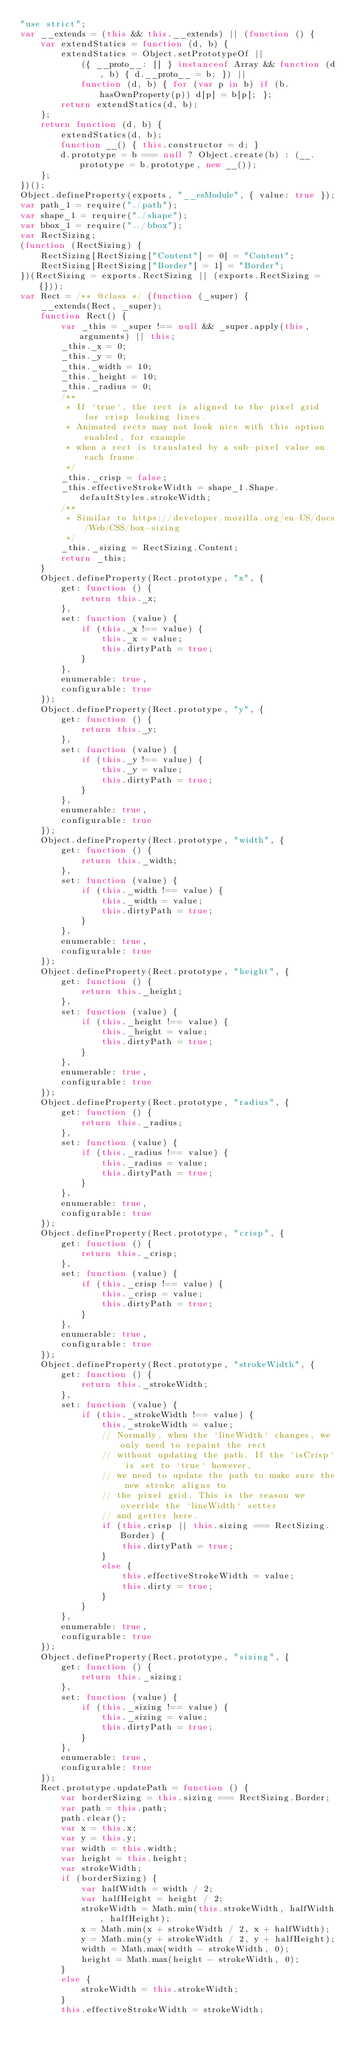<code> <loc_0><loc_0><loc_500><loc_500><_JavaScript_>"use strict";
var __extends = (this && this.__extends) || (function () {
    var extendStatics = function (d, b) {
        extendStatics = Object.setPrototypeOf ||
            ({ __proto__: [] } instanceof Array && function (d, b) { d.__proto__ = b; }) ||
            function (d, b) { for (var p in b) if (b.hasOwnProperty(p)) d[p] = b[p]; };
        return extendStatics(d, b);
    };
    return function (d, b) {
        extendStatics(d, b);
        function __() { this.constructor = d; }
        d.prototype = b === null ? Object.create(b) : (__.prototype = b.prototype, new __());
    };
})();
Object.defineProperty(exports, "__esModule", { value: true });
var path_1 = require("./path");
var shape_1 = require("./shape");
var bbox_1 = require("../bbox");
var RectSizing;
(function (RectSizing) {
    RectSizing[RectSizing["Content"] = 0] = "Content";
    RectSizing[RectSizing["Border"] = 1] = "Border";
})(RectSizing = exports.RectSizing || (exports.RectSizing = {}));
var Rect = /** @class */ (function (_super) {
    __extends(Rect, _super);
    function Rect() {
        var _this = _super !== null && _super.apply(this, arguments) || this;
        _this._x = 0;
        _this._y = 0;
        _this._width = 10;
        _this._height = 10;
        _this._radius = 0;
        /**
         * If `true`, the rect is aligned to the pixel grid for crisp looking lines.
         * Animated rects may not look nice with this option enabled, for example
         * when a rect is translated by a sub-pixel value on each frame.
         */
        _this._crisp = false;
        _this.effectiveStrokeWidth = shape_1.Shape.defaultStyles.strokeWidth;
        /**
         * Similar to https://developer.mozilla.org/en-US/docs/Web/CSS/box-sizing
         */
        _this._sizing = RectSizing.Content;
        return _this;
    }
    Object.defineProperty(Rect.prototype, "x", {
        get: function () {
            return this._x;
        },
        set: function (value) {
            if (this._x !== value) {
                this._x = value;
                this.dirtyPath = true;
            }
        },
        enumerable: true,
        configurable: true
    });
    Object.defineProperty(Rect.prototype, "y", {
        get: function () {
            return this._y;
        },
        set: function (value) {
            if (this._y !== value) {
                this._y = value;
                this.dirtyPath = true;
            }
        },
        enumerable: true,
        configurable: true
    });
    Object.defineProperty(Rect.prototype, "width", {
        get: function () {
            return this._width;
        },
        set: function (value) {
            if (this._width !== value) {
                this._width = value;
                this.dirtyPath = true;
            }
        },
        enumerable: true,
        configurable: true
    });
    Object.defineProperty(Rect.prototype, "height", {
        get: function () {
            return this._height;
        },
        set: function (value) {
            if (this._height !== value) {
                this._height = value;
                this.dirtyPath = true;
            }
        },
        enumerable: true,
        configurable: true
    });
    Object.defineProperty(Rect.prototype, "radius", {
        get: function () {
            return this._radius;
        },
        set: function (value) {
            if (this._radius !== value) {
                this._radius = value;
                this.dirtyPath = true;
            }
        },
        enumerable: true,
        configurable: true
    });
    Object.defineProperty(Rect.prototype, "crisp", {
        get: function () {
            return this._crisp;
        },
        set: function (value) {
            if (this._crisp !== value) {
                this._crisp = value;
                this.dirtyPath = true;
            }
        },
        enumerable: true,
        configurable: true
    });
    Object.defineProperty(Rect.prototype, "strokeWidth", {
        get: function () {
            return this._strokeWidth;
        },
        set: function (value) {
            if (this._strokeWidth !== value) {
                this._strokeWidth = value;
                // Normally, when the `lineWidth` changes, we only need to repaint the rect
                // without updating the path. If the `isCrisp` is set to `true` however,
                // we need to update the path to make sure the new stroke aligns to
                // the pixel grid. This is the reason we override the `lineWidth` setter
                // and getter here.
                if (this.crisp || this.sizing === RectSizing.Border) {
                    this.dirtyPath = true;
                }
                else {
                    this.effectiveStrokeWidth = value;
                    this.dirty = true;
                }
            }
        },
        enumerable: true,
        configurable: true
    });
    Object.defineProperty(Rect.prototype, "sizing", {
        get: function () {
            return this._sizing;
        },
        set: function (value) {
            if (this._sizing !== value) {
                this._sizing = value;
                this.dirtyPath = true;
            }
        },
        enumerable: true,
        configurable: true
    });
    Rect.prototype.updatePath = function () {
        var borderSizing = this.sizing === RectSizing.Border;
        var path = this.path;
        path.clear();
        var x = this.x;
        var y = this.y;
        var width = this.width;
        var height = this.height;
        var strokeWidth;
        if (borderSizing) {
            var halfWidth = width / 2;
            var halfHeight = height / 2;
            strokeWidth = Math.min(this.strokeWidth, halfWidth, halfHeight);
            x = Math.min(x + strokeWidth / 2, x + halfWidth);
            y = Math.min(y + strokeWidth / 2, y + halfHeight);
            width = Math.max(width - strokeWidth, 0);
            height = Math.max(height - strokeWidth, 0);
        }
        else {
            strokeWidth = this.strokeWidth;
        }
        this.effectiveStrokeWidth = strokeWidth;</code> 